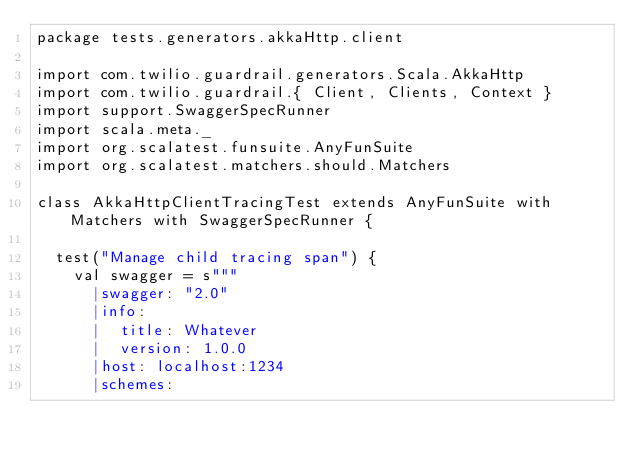Convert code to text. <code><loc_0><loc_0><loc_500><loc_500><_Scala_>package tests.generators.akkaHttp.client

import com.twilio.guardrail.generators.Scala.AkkaHttp
import com.twilio.guardrail.{ Client, Clients, Context }
import support.SwaggerSpecRunner
import scala.meta._
import org.scalatest.funsuite.AnyFunSuite
import org.scalatest.matchers.should.Matchers

class AkkaHttpClientTracingTest extends AnyFunSuite with Matchers with SwaggerSpecRunner {

  test("Manage child tracing span") {
    val swagger = s"""
      |swagger: "2.0"
      |info:
      |  title: Whatever
      |  version: 1.0.0
      |host: localhost:1234
      |schemes:</code> 